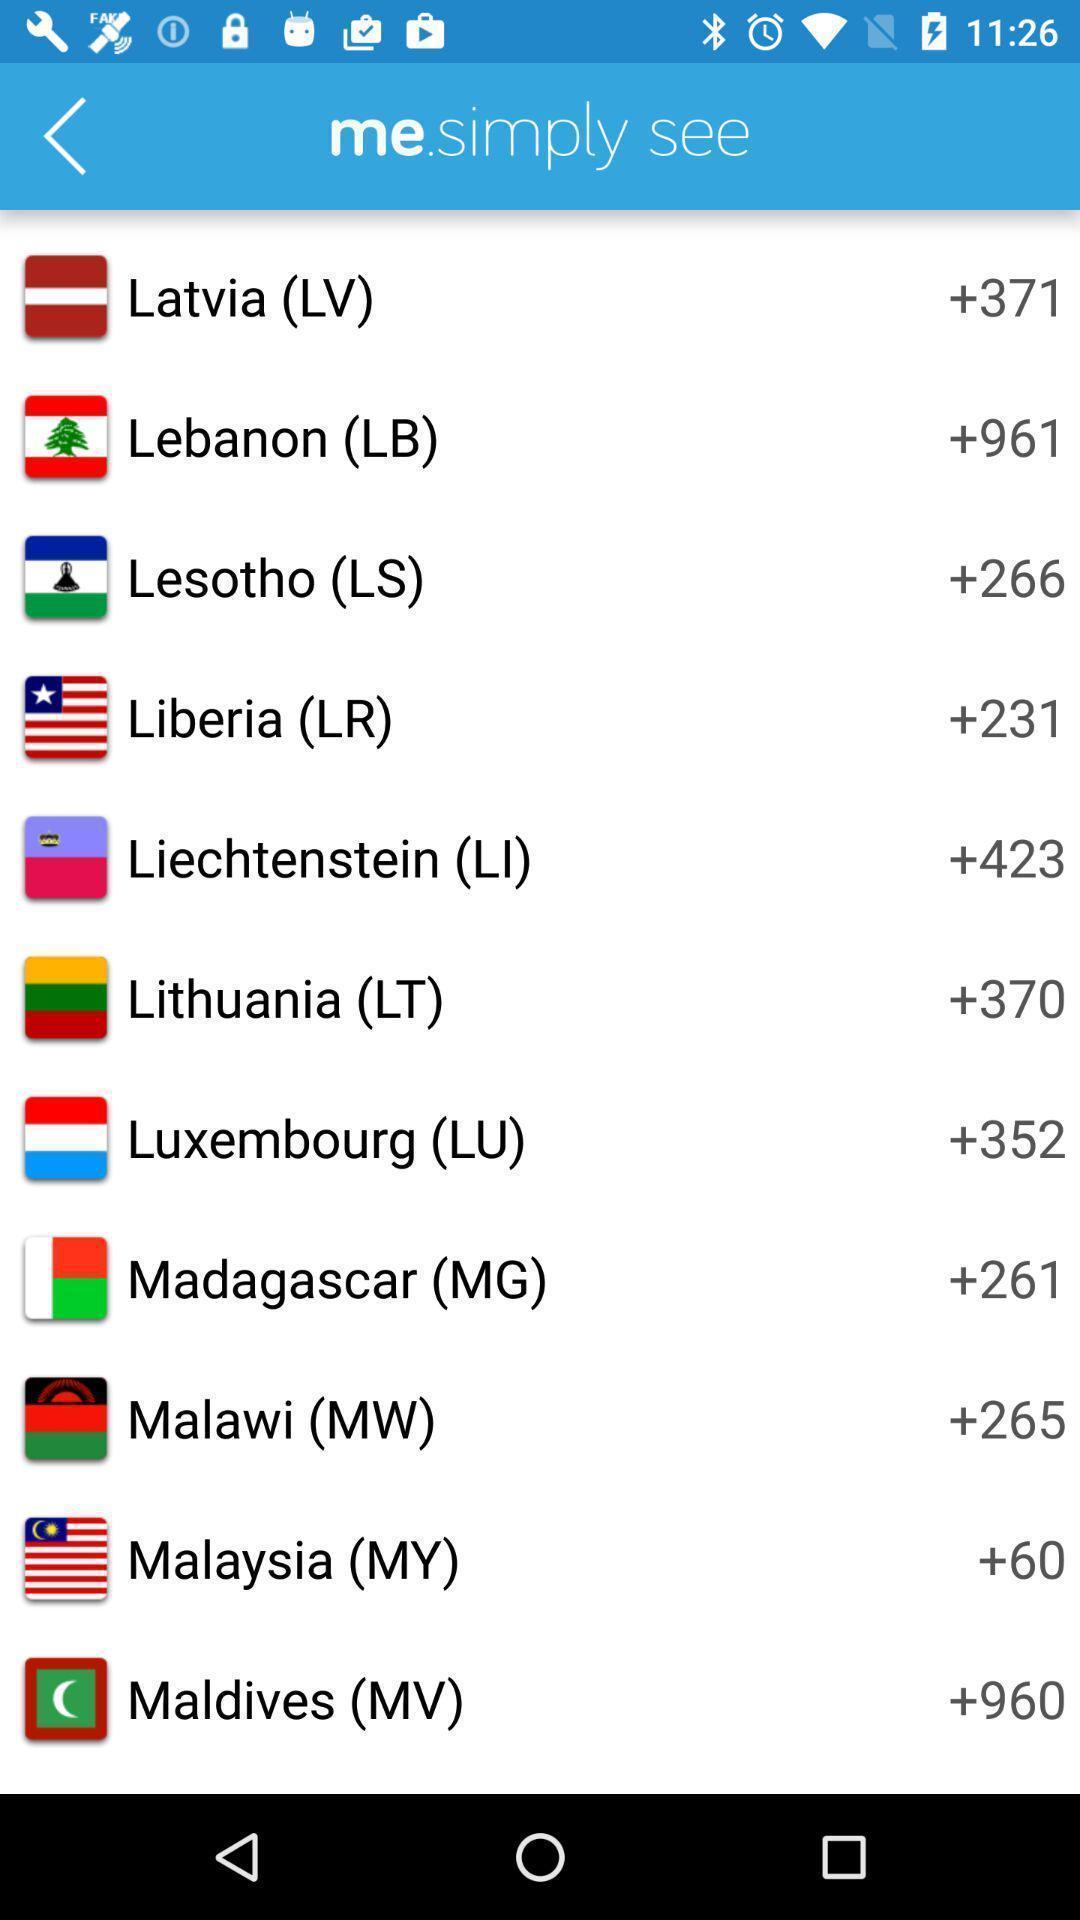Give me a summary of this screen capture. Screen displaying list of countries with calling codes. 